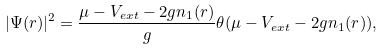Convert formula to latex. <formula><loc_0><loc_0><loc_500><loc_500>| \Psi ( r ) | ^ { 2 } = \frac { \mu - V _ { e x t } - 2 g n _ { 1 } ( r ) } { g } \theta ( \mu - V _ { e x t } - 2 g n _ { 1 } ( r ) ) ,</formula> 